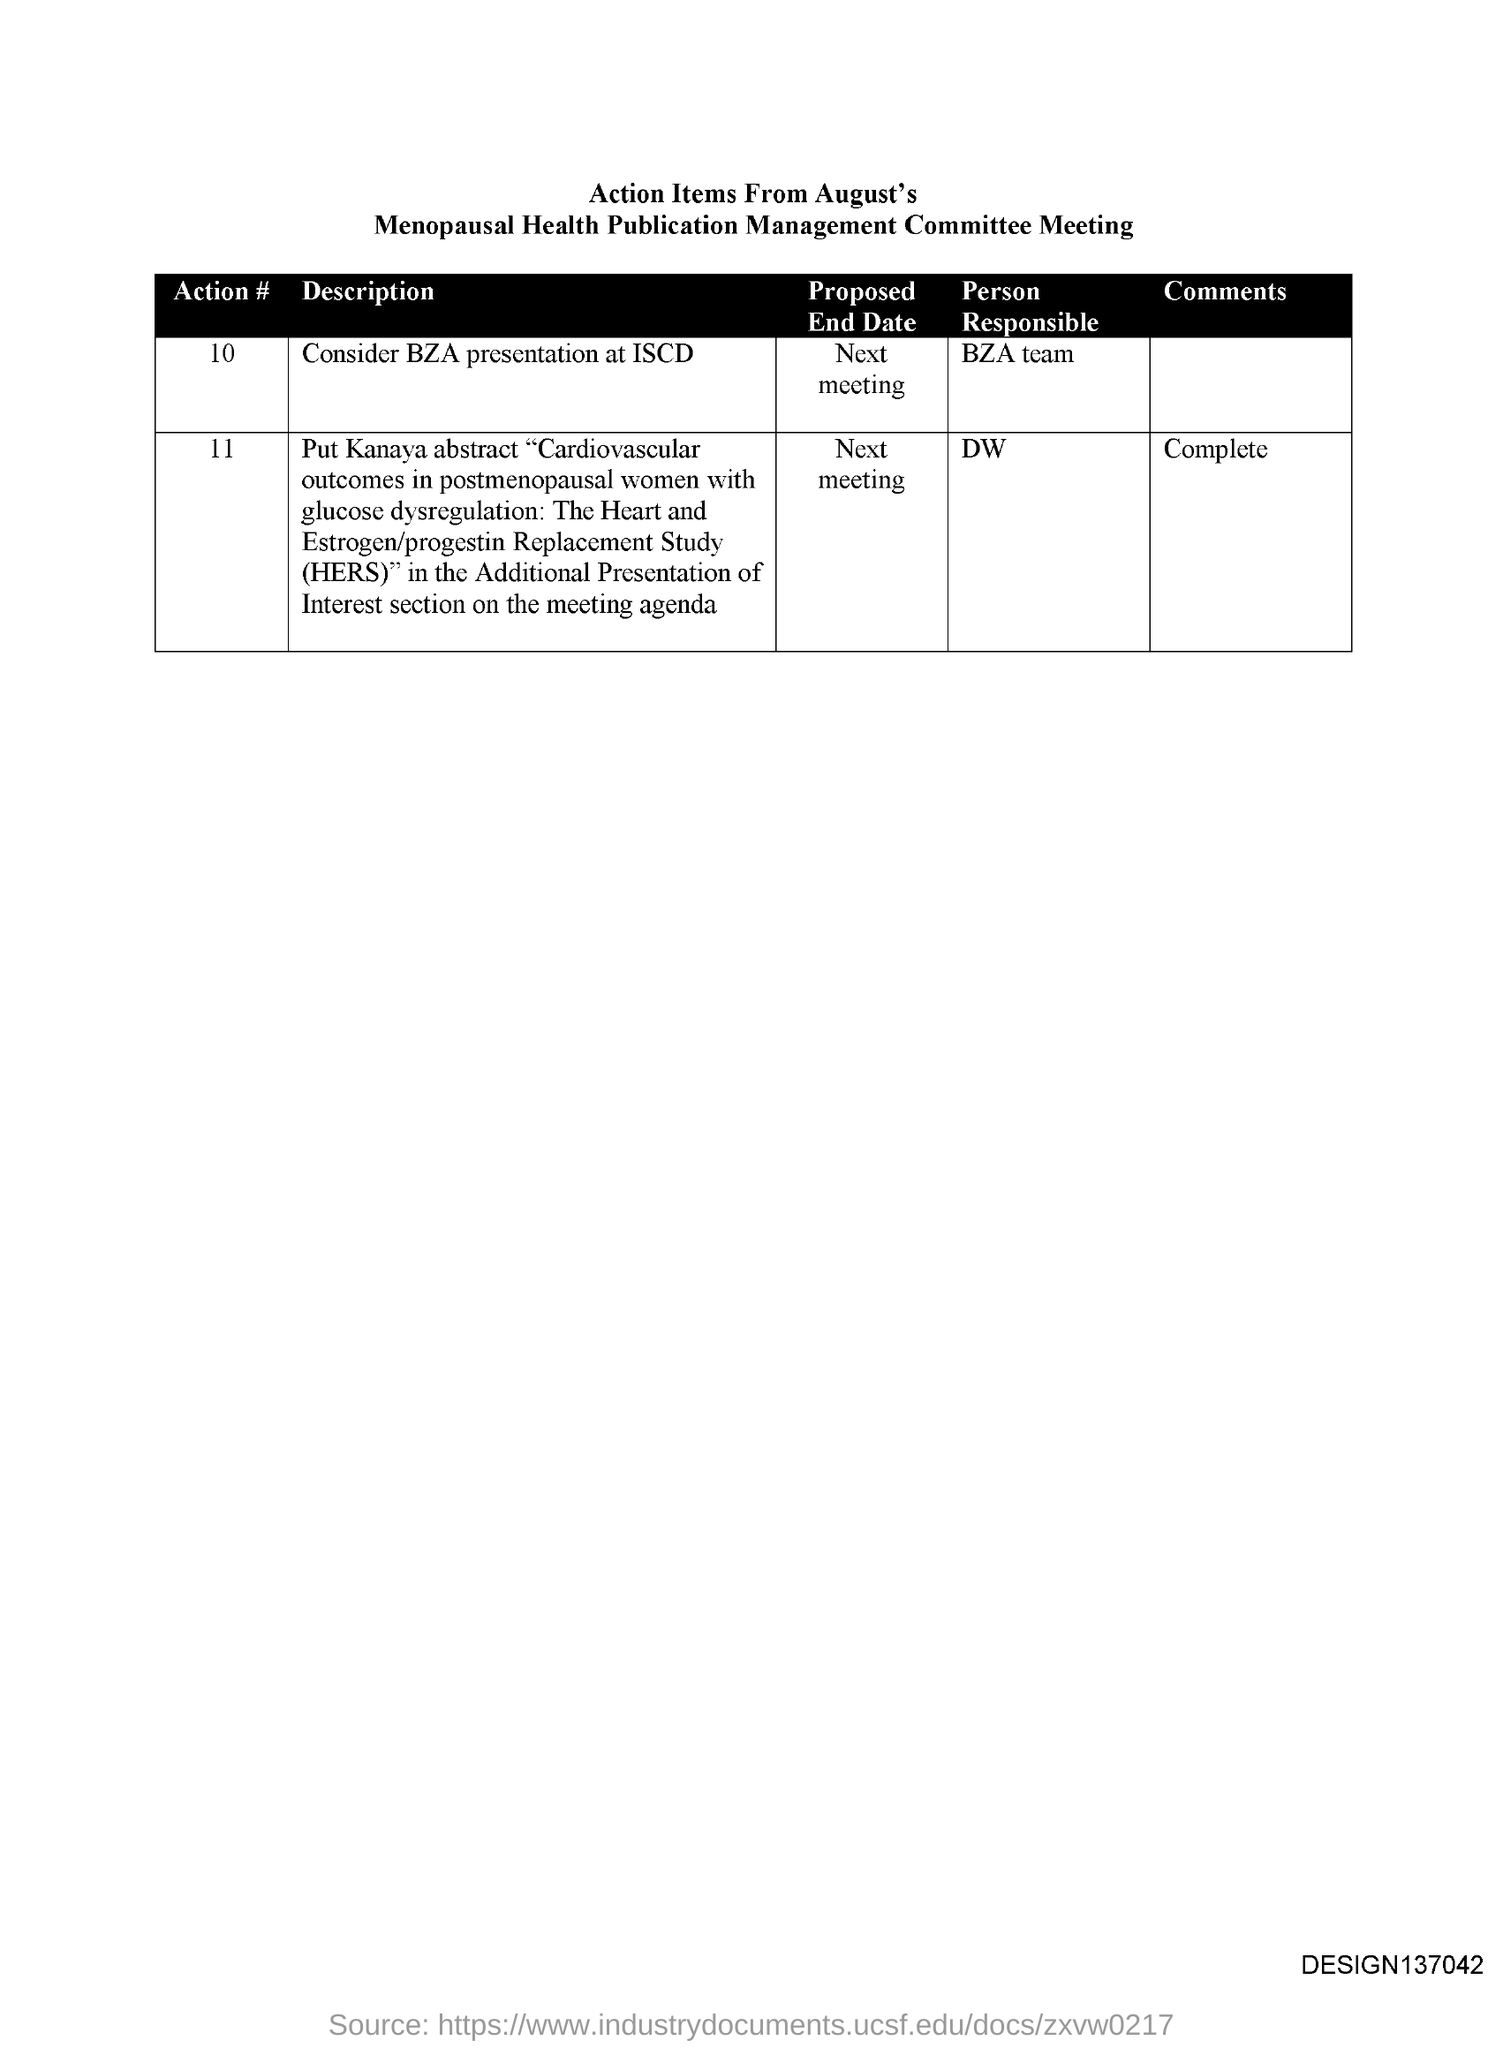Outline some significant characteristics in this image. The BZA team is responsible for action #10. The person responsible for action #11 is unknown. 